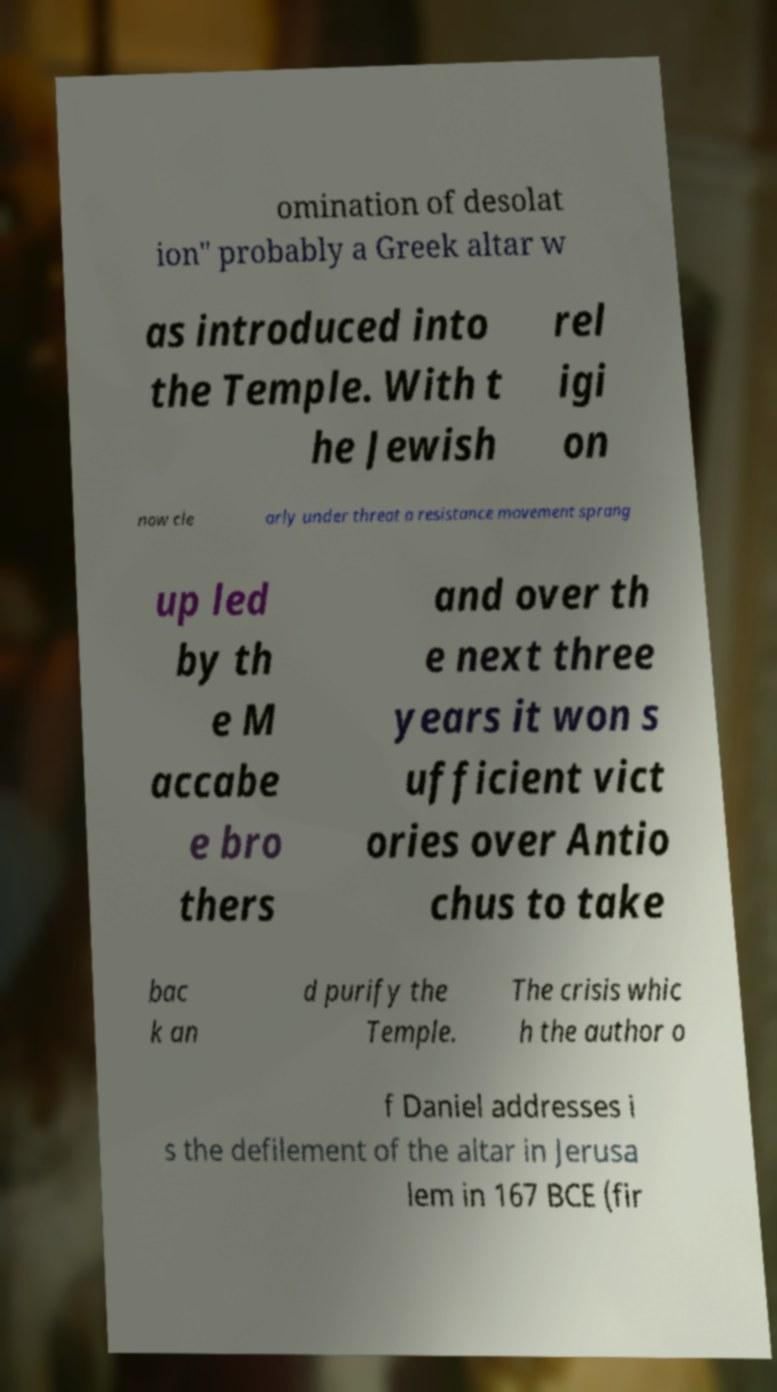Please identify and transcribe the text found in this image. omination of desolat ion" probably a Greek altar w as introduced into the Temple. With t he Jewish rel igi on now cle arly under threat a resistance movement sprang up led by th e M accabe e bro thers and over th e next three years it won s ufficient vict ories over Antio chus to take bac k an d purify the Temple. The crisis whic h the author o f Daniel addresses i s the defilement of the altar in Jerusa lem in 167 BCE (fir 